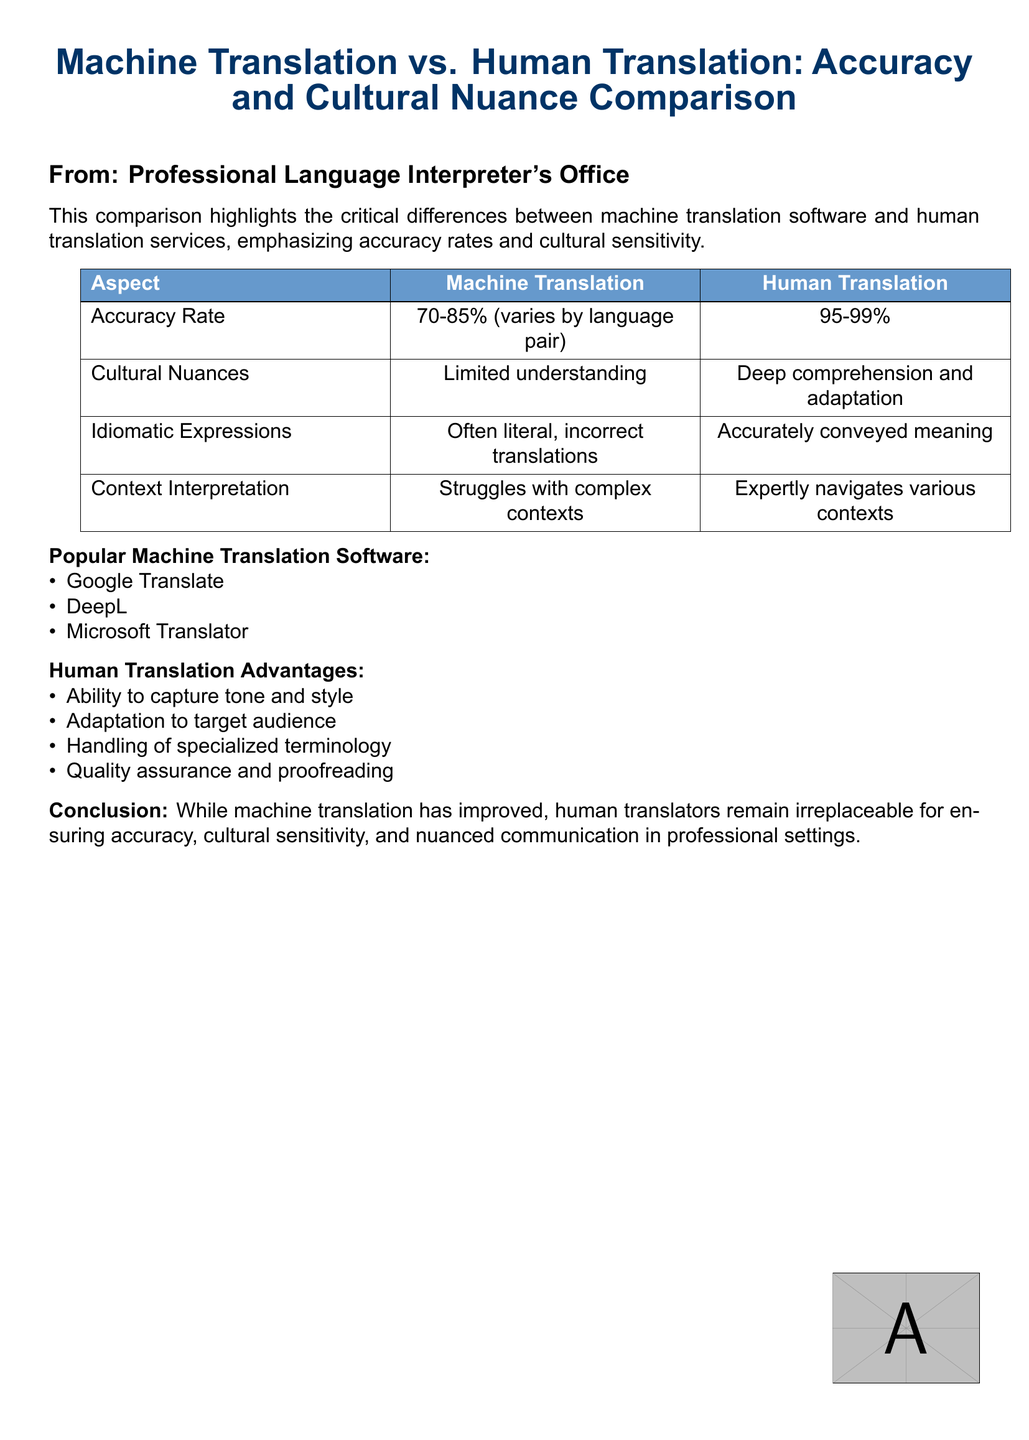What is the title of the document? The title of the document is highlighted at the top and states the main topic of the comparison.
Answer: Machine Translation vs. Human Translation: Accuracy and Cultural Nuance Comparison What is the accuracy rate range for machine translation? The accuracy rate for machine translation is specified in the comparison chart within the document.
Answer: 70-85% What does human translation's accuracy rate range? The human translation's accuracy rate is provided in the chart section of the document.
Answer: 95-99% Which software is mentioned first under popular machine translation software? The first item listed in the popular machine translation software section can be found in the document's itemized list.
Answer: Google Translate What aspect shows human translation’s strength compared to machine translation? The advantages listed for human translation highlight strengths over machine translation.
Answer: Ability to capture tone and style Which aspect indicates limited understanding in machine translation? The comparison chart specifically states a limitation of machine translation in relation to understanding.
Answer: Cultural Nuances What can human translators expertly navigate? This information is included in the comparison chart discussing human translators’ capabilities.
Answer: Various contexts What is the conclusion regarding the value of human translators? The conclusion offers a final statement about the indispensable role of human translators in a specific context.
Answer: Irreplaceable for ensuring accuracy, cultural sensitivity, and nuanced communication in professional settings 